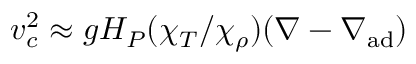<formula> <loc_0><loc_0><loc_500><loc_500>v _ { c } ^ { 2 } \approx g H _ { P } ( \chi _ { T } / \chi _ { \rho } ) ( \nabla - \nabla _ { a d } )</formula> 